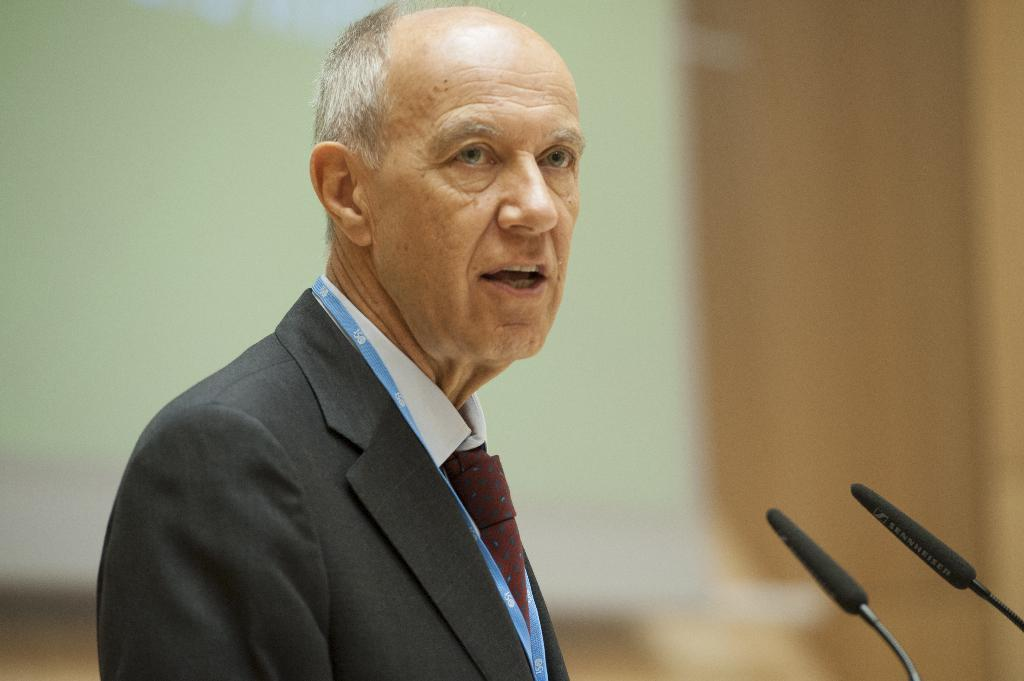Who is the main subject in the image? There is a man in the image. What is the man wearing? The man is wearing a black blazer. What objects are located on the right side of the man? There are microphones on the right side of the man. How would you describe the background of the image? The background of the image is blurred. How many brothers does the man have in the image? There is no information about the man's brothers in the image. What type of cream is being used by the band in the image? There is no band or cream present in the image. 